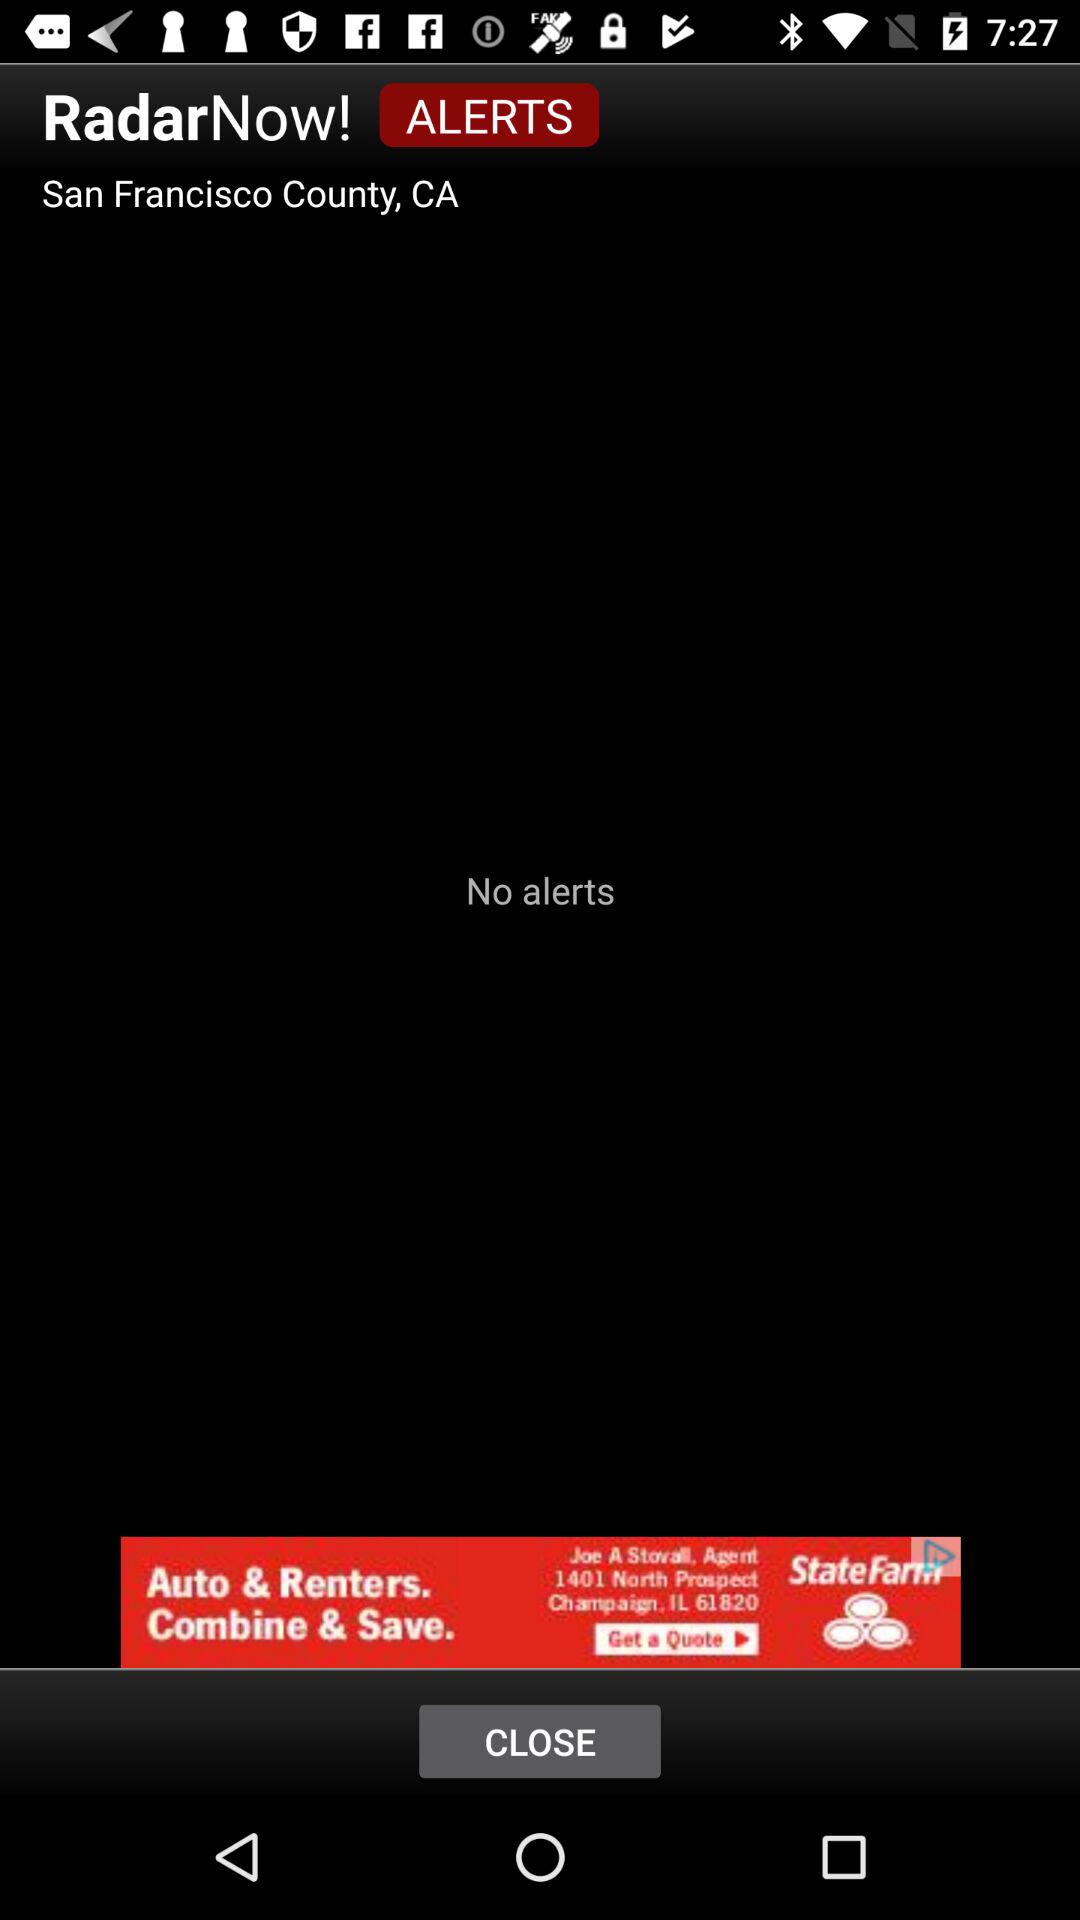Are there any alerts? There are no alerts. 